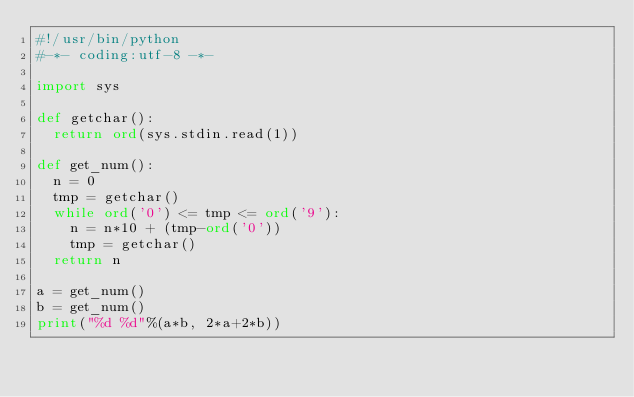<code> <loc_0><loc_0><loc_500><loc_500><_Python_>#!/usr/bin/python 
#-*- coding:utf-8 -*-

import sys

def getchar():
  return ord(sys.stdin.read(1))

def get_num():
  n = 0
  tmp = getchar()
  while ord('0') <= tmp <= ord('9'):
    n = n*10 + (tmp-ord('0'))
    tmp = getchar()
  return n

a = get_num()
b = get_num()
print("%d %d"%(a*b, 2*a+2*b))</code> 